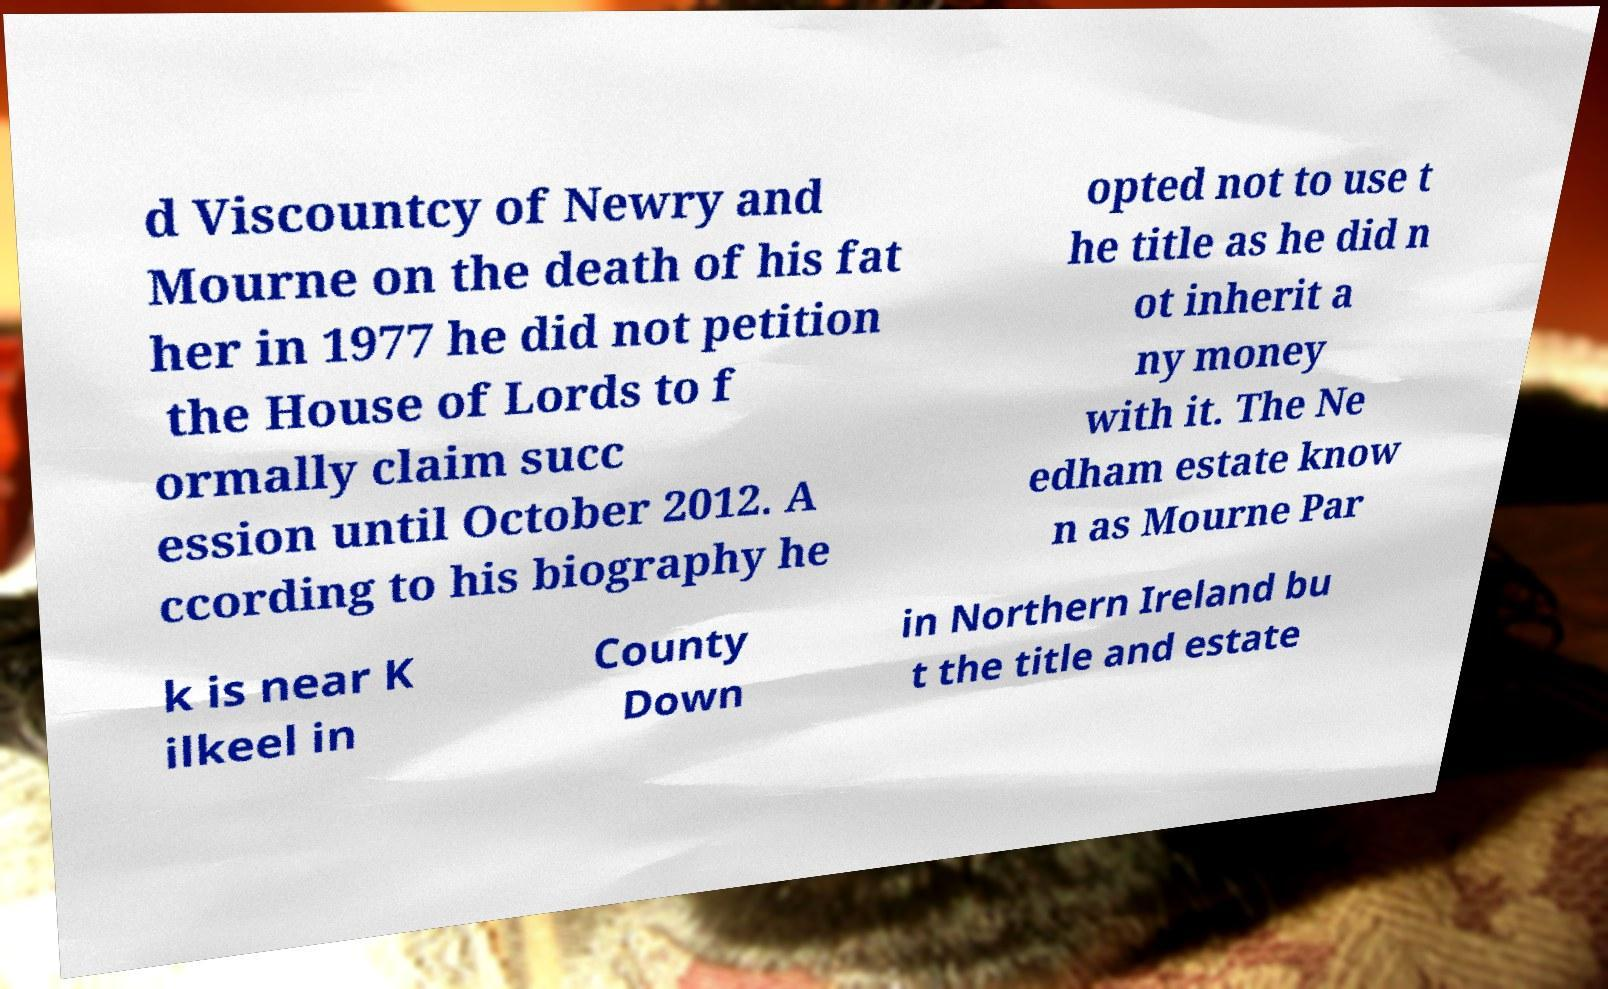Please identify and transcribe the text found in this image. d Viscountcy of Newry and Mourne on the death of his fat her in 1977 he did not petition the House of Lords to f ormally claim succ ession until October 2012. A ccording to his biography he opted not to use t he title as he did n ot inherit a ny money with it. The Ne edham estate know n as Mourne Par k is near K ilkeel in County Down in Northern Ireland bu t the title and estate 